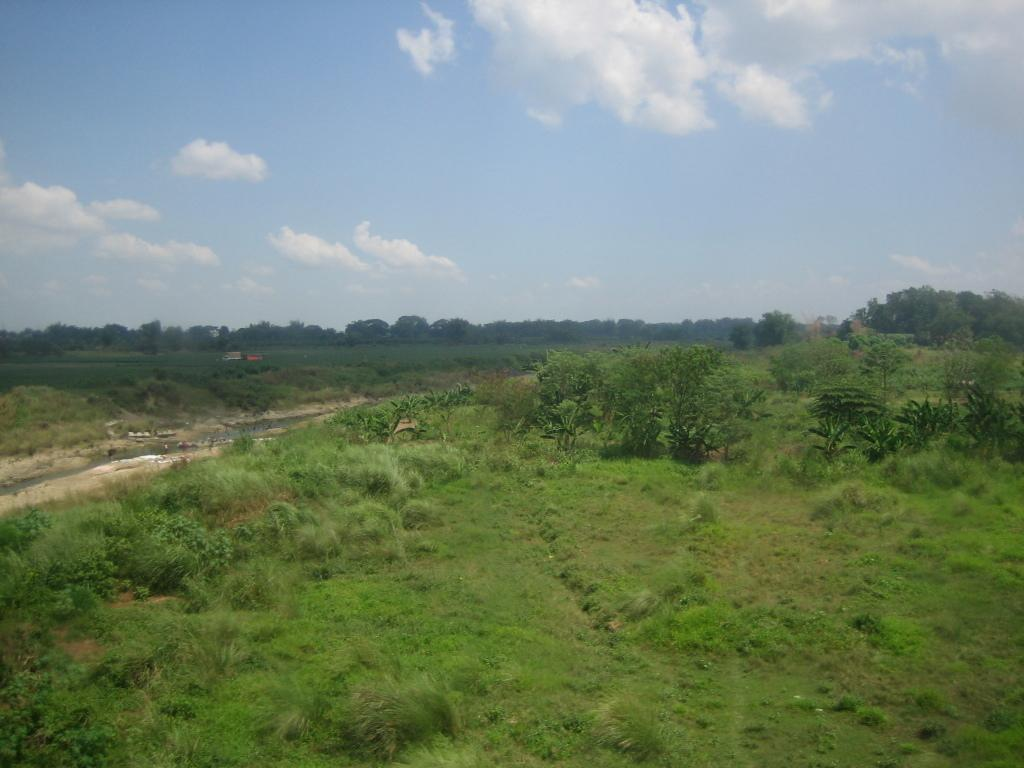What type of vegetation can be seen in the image? There are plants in the image. What is on the ground in the image? There is grass on the ground in the image. What can be seen in the background of the image? There are trees and clouds in the sky in the background of the image. How many houses are visible in the image? There are no houses visible in the image; it features plants, grass, trees, and clouds. What type of bird can be seen perched on the plants in the image? There are no birds present in the image; it only features plants, grass, trees, and clouds. 